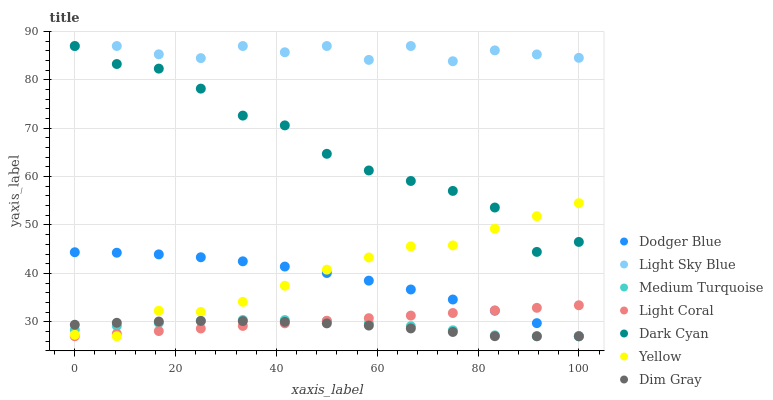Does Dim Gray have the minimum area under the curve?
Answer yes or no. Yes. Does Light Sky Blue have the maximum area under the curve?
Answer yes or no. Yes. Does Yellow have the minimum area under the curve?
Answer yes or no. No. Does Yellow have the maximum area under the curve?
Answer yes or no. No. Is Light Coral the smoothest?
Answer yes or no. Yes. Is Dark Cyan the roughest?
Answer yes or no. Yes. Is Yellow the smoothest?
Answer yes or no. No. Is Yellow the roughest?
Answer yes or no. No. Does Dim Gray have the lowest value?
Answer yes or no. Yes. Does Light Sky Blue have the lowest value?
Answer yes or no. No. Does Dark Cyan have the highest value?
Answer yes or no. Yes. Does Yellow have the highest value?
Answer yes or no. No. Is Dim Gray less than Light Sky Blue?
Answer yes or no. Yes. Is Dark Cyan greater than Dodger Blue?
Answer yes or no. Yes. Does Dodger Blue intersect Dim Gray?
Answer yes or no. Yes. Is Dodger Blue less than Dim Gray?
Answer yes or no. No. Is Dodger Blue greater than Dim Gray?
Answer yes or no. No. Does Dim Gray intersect Light Sky Blue?
Answer yes or no. No. 